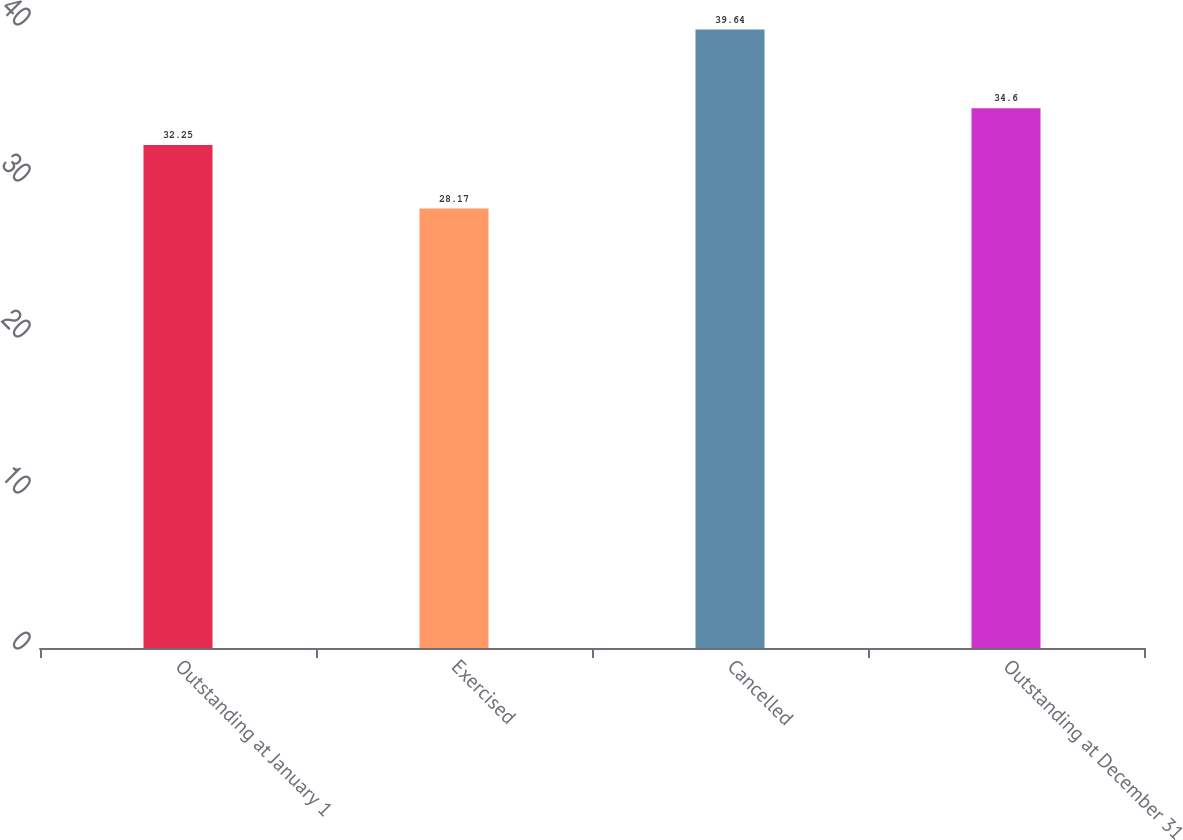Convert chart to OTSL. <chart><loc_0><loc_0><loc_500><loc_500><bar_chart><fcel>Outstanding at January 1<fcel>Exercised<fcel>Cancelled<fcel>Outstanding at December 31<nl><fcel>32.25<fcel>28.17<fcel>39.64<fcel>34.6<nl></chart> 